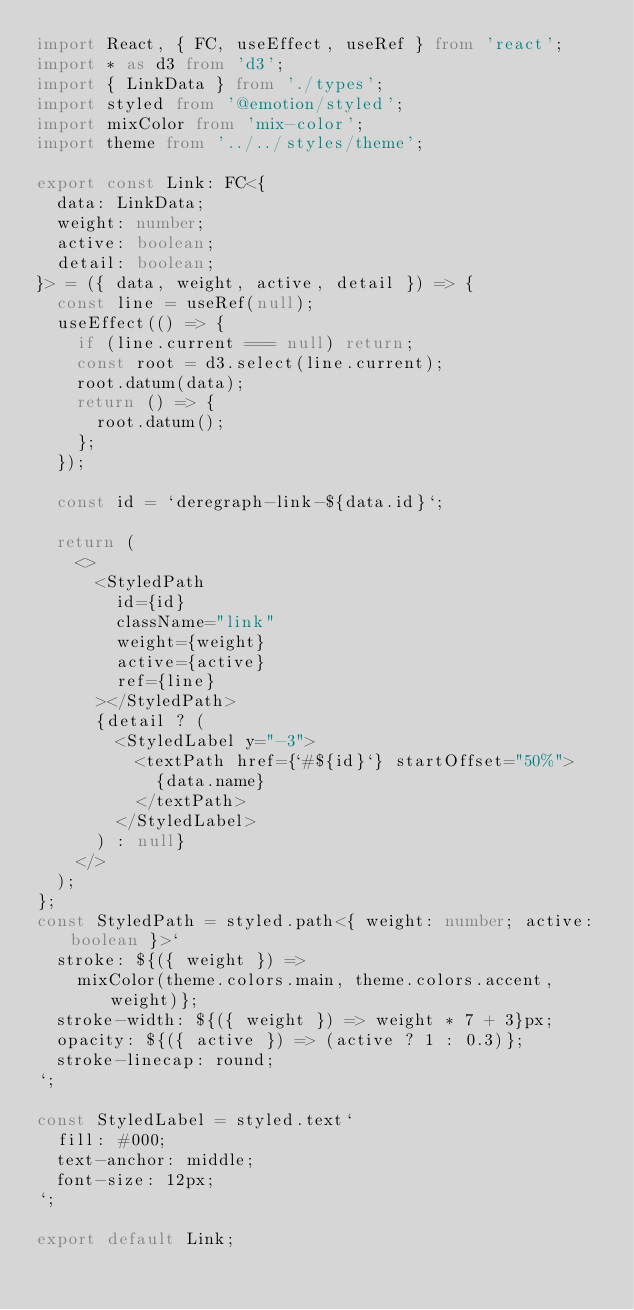Convert code to text. <code><loc_0><loc_0><loc_500><loc_500><_TypeScript_>import React, { FC, useEffect, useRef } from 'react';
import * as d3 from 'd3';
import { LinkData } from './types';
import styled from '@emotion/styled';
import mixColor from 'mix-color';
import theme from '../../styles/theme';

export const Link: FC<{
  data: LinkData;
  weight: number;
  active: boolean;
  detail: boolean;
}> = ({ data, weight, active, detail }) => {
  const line = useRef(null);
  useEffect(() => {
    if (line.current === null) return;
    const root = d3.select(line.current);
    root.datum(data);
    return () => {
      root.datum();
    };
  });

  const id = `deregraph-link-${data.id}`;

  return (
    <>
      <StyledPath
        id={id}
        className="link"
        weight={weight}
        active={active}
        ref={line}
      ></StyledPath>
      {detail ? (
        <StyledLabel y="-3">
          <textPath href={`#${id}`} startOffset="50%">
            {data.name}
          </textPath>
        </StyledLabel>
      ) : null}
    </>
  );
};
const StyledPath = styled.path<{ weight: number; active: boolean }>`
  stroke: ${({ weight }) =>
    mixColor(theme.colors.main, theme.colors.accent, weight)};
  stroke-width: ${({ weight }) => weight * 7 + 3}px;
  opacity: ${({ active }) => (active ? 1 : 0.3)};
  stroke-linecap: round;
`;

const StyledLabel = styled.text`
  fill: #000;
  text-anchor: middle;
  font-size: 12px;
`;

export default Link;
</code> 